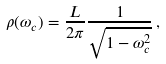Convert formula to latex. <formula><loc_0><loc_0><loc_500><loc_500>\rho ( \omega _ { c } ) = \frac { L } { 2 \pi } \frac { 1 } { \sqrt { 1 - \omega _ { c } ^ { 2 } } } \, ,</formula> 